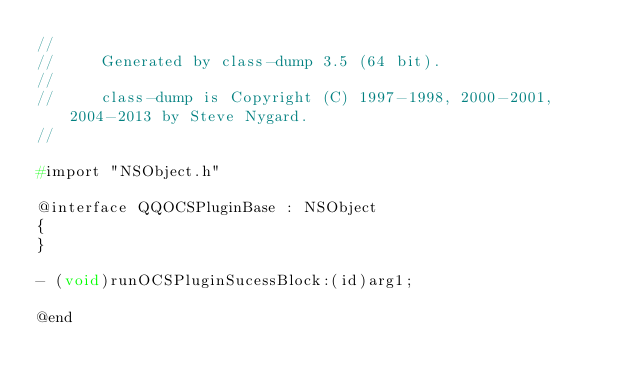<code> <loc_0><loc_0><loc_500><loc_500><_C_>//
//     Generated by class-dump 3.5 (64 bit).
//
//     class-dump is Copyright (C) 1997-1998, 2000-2001, 2004-2013 by Steve Nygard.
//

#import "NSObject.h"

@interface QQOCSPluginBase : NSObject
{
}

- (void)runOCSPluginSucessBlock:(id)arg1;

@end

</code> 